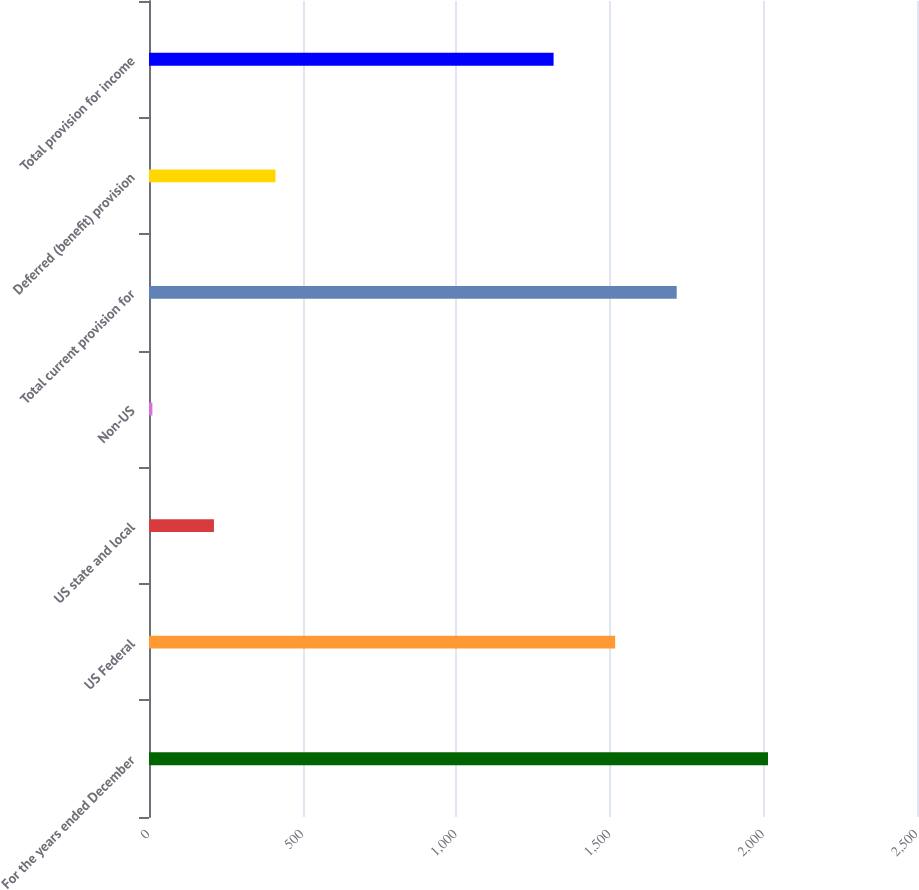<chart> <loc_0><loc_0><loc_500><loc_500><bar_chart><fcel>For the years ended December<fcel>US Federal<fcel>US state and local<fcel>Non-US<fcel>Total current provision for<fcel>Deferred (benefit) provision<fcel>Total provision for income<nl><fcel>2015<fcel>1517.4<fcel>211.4<fcel>11<fcel>1717.8<fcel>411.8<fcel>1317<nl></chart> 